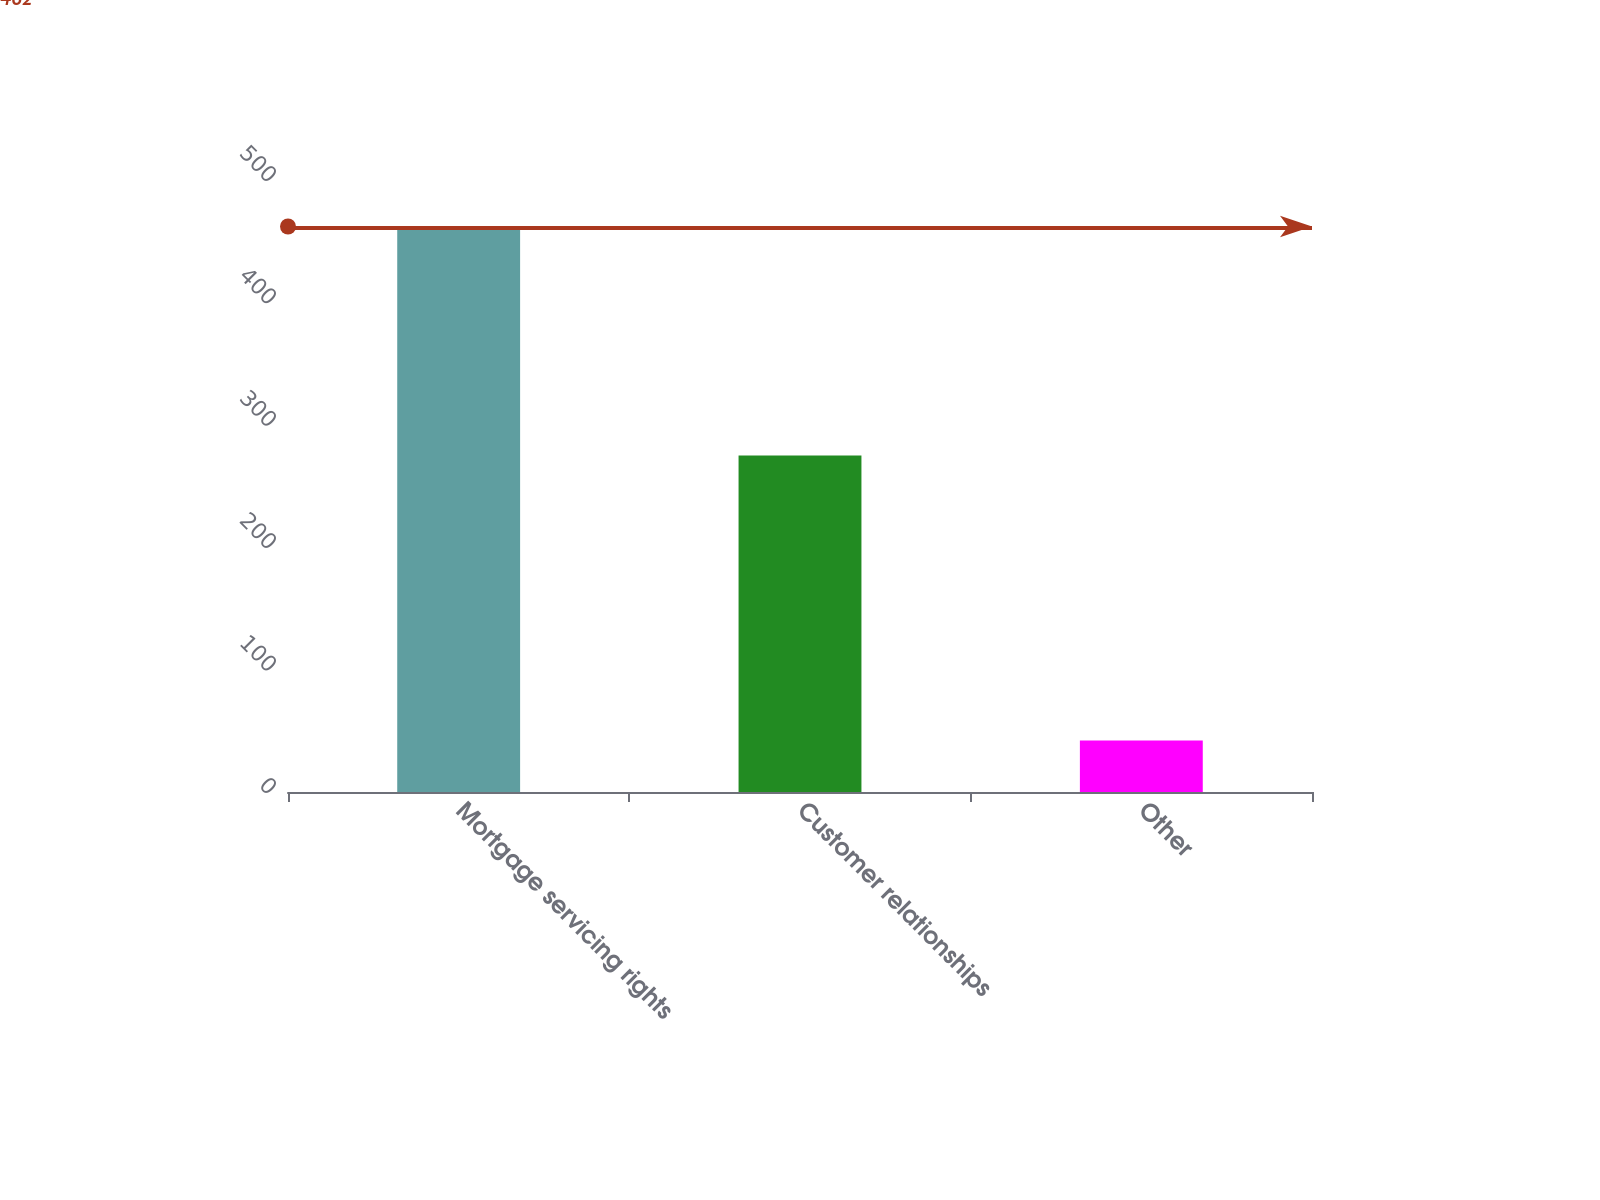<chart> <loc_0><loc_0><loc_500><loc_500><bar_chart><fcel>Mortgage servicing rights<fcel>Customer relationships<fcel>Other<nl><fcel>462<fcel>275<fcel>42<nl></chart> 